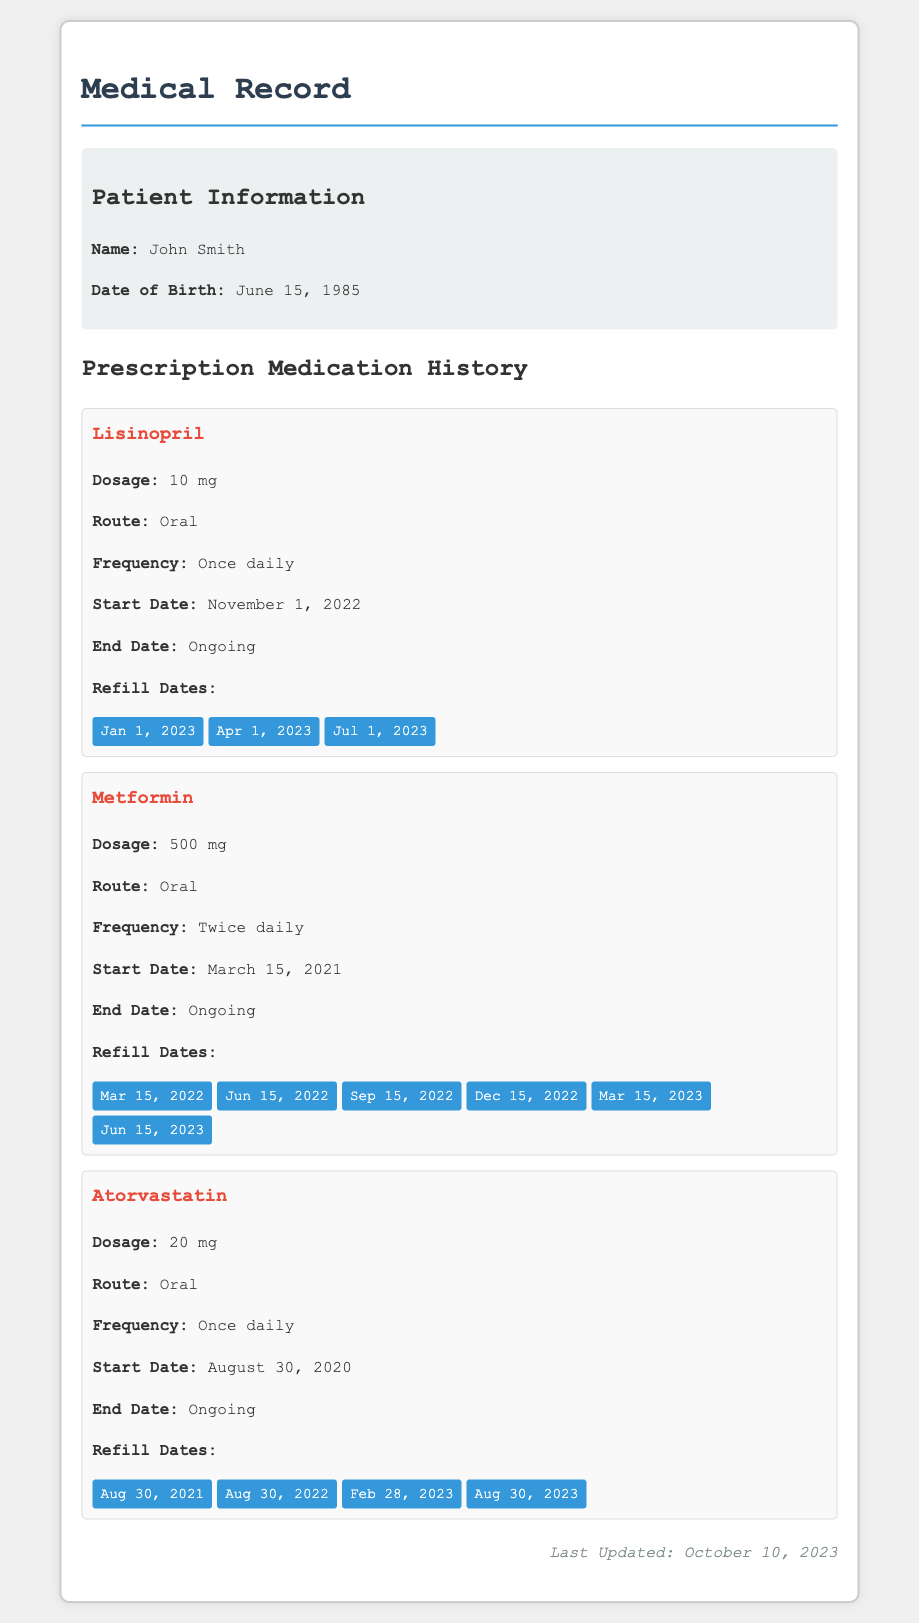what is the name of the patient? The document lists the patient's name at the top of the patient information section.
Answer: John Smith what is the dosage of Lisinopril? The dosage of Lisinopril is mentioned directly under the medication details.
Answer: 10 mg how often is Metformin taken? The frequency of Metformin usage is specified in the medication details.
Answer: Twice daily when was the last refill for Atorvastatin? The last refill date is the most recent entry in the refill dates section for Atorvastatin.
Answer: Aug 30, 2023 what is the route of administration for Metformin? The route of administration is clearly listed in the medication details of Metformin.
Answer: Oral how many refill dates are there for Lisinopril? The number of refill dates can be counted from the provided refill dates section for Lisinopril.
Answer: 3 is the prescription for Atorvastatin ongoing? The end date section for Atorvastatin indicates the current status of the prescription.
Answer: Ongoing which medication was started on November 1, 2022? The start date for Lisinopril is listed in the medication section.
Answer: Lisinopril how many times was Metformin refilled up to March 2023? The refill dates for Metformin are counted up to the date in question.
Answer: 5 